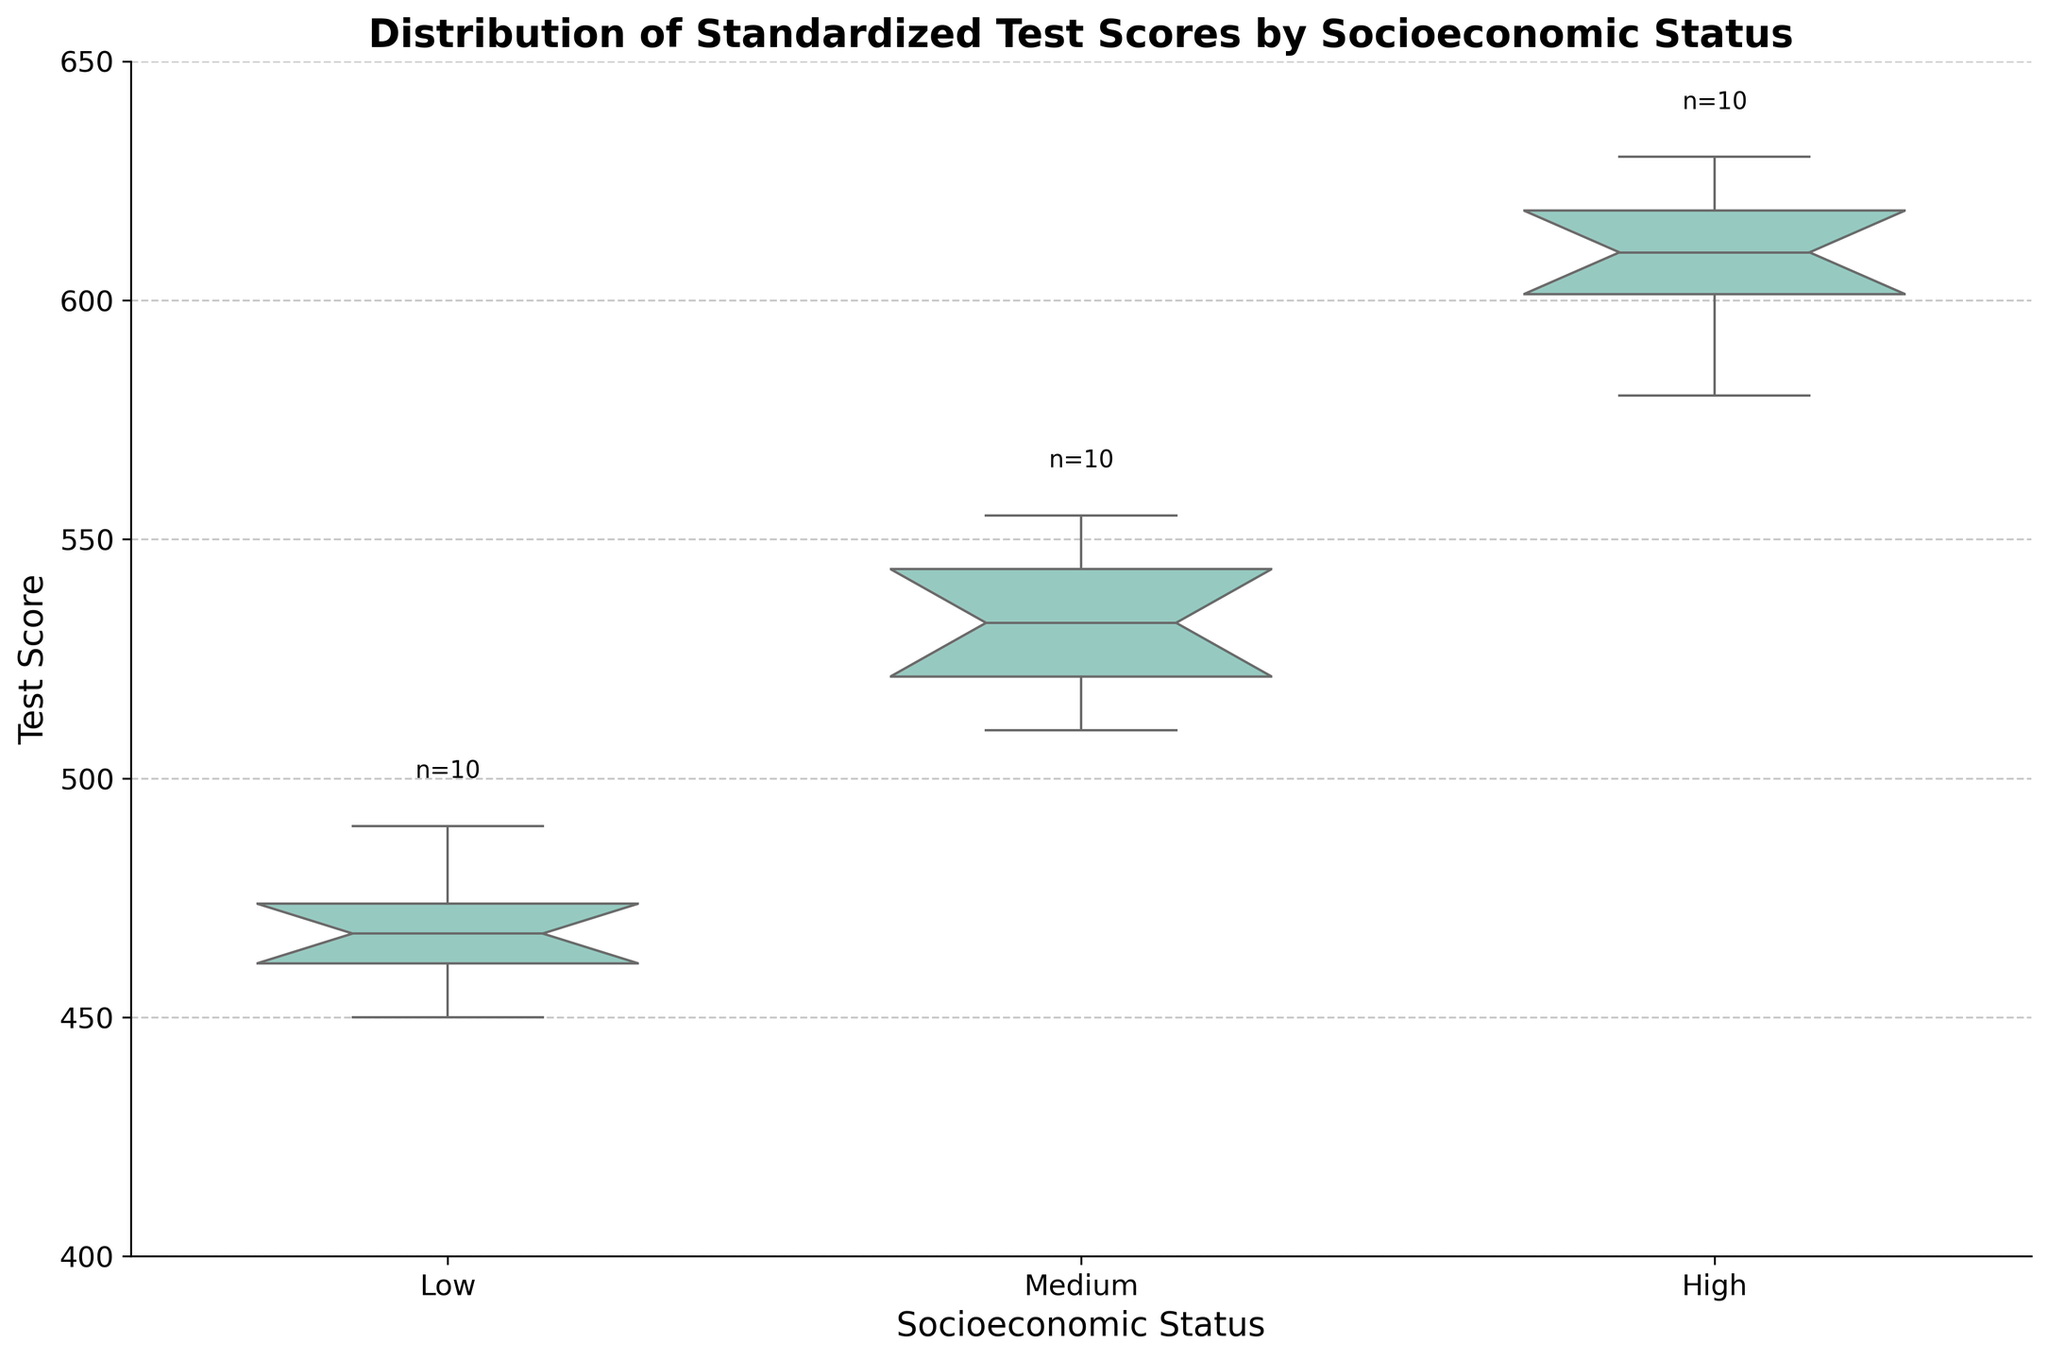What is the title of the figure? The title is displayed at the top of the figure.
Answer: Distribution of Standardized Test Scores by Socioeconomic Status What are the categories on the x-axis? The categories along the x-axis represent different socioeconomic statuses.
Answer: Low, Medium, High What is the range of the y-axis? The range of the y-axis can be determined by examining the limits of the axis.
Answer: 400 to 650 Which socioeconomic status category has the highest maximum score? By comparing the maximum scores of the box plots, the highest maximum score can be identified.
Answer: High Which socioeconomic status category has the smallest interquartile range (IQR)? The IQR is the range between the first quartile (Q1) and the third quartile (Q3). By comparing the IQRs of each box plot, the smallest can be determined.
Answer: Medium What is the median score for the low SES category? The median score is represented by the horizontal line within the box of the low SES category.
Answer: Approximately 470 Which SES category has the largest number of data points? The number of data points for each category is annotated above each box plot. The largest number can be identified by comparing these annotations.
Answer: Medium (10 data points) What is the difference between the median scores of the High and Low SES categories? The median scores of the High and Low SES categories can be identified from the box plots, and their difference can be calculated.
Answer: Approximately 140 How does the spread of test scores in the Low SES category compare to the Medium SES category? The spread can be compared by analyzing the ranges and whiskers of the box plots for the Low and Medium SES categories.
Answer: Low SES has a larger spread Why do some box plots have notches? The notches around the median represent the 95% confidence interval for the median, which helps to visually assess if the medians of different groups are significantly different.
Answer: To represent the 95% confidence interval for the median 